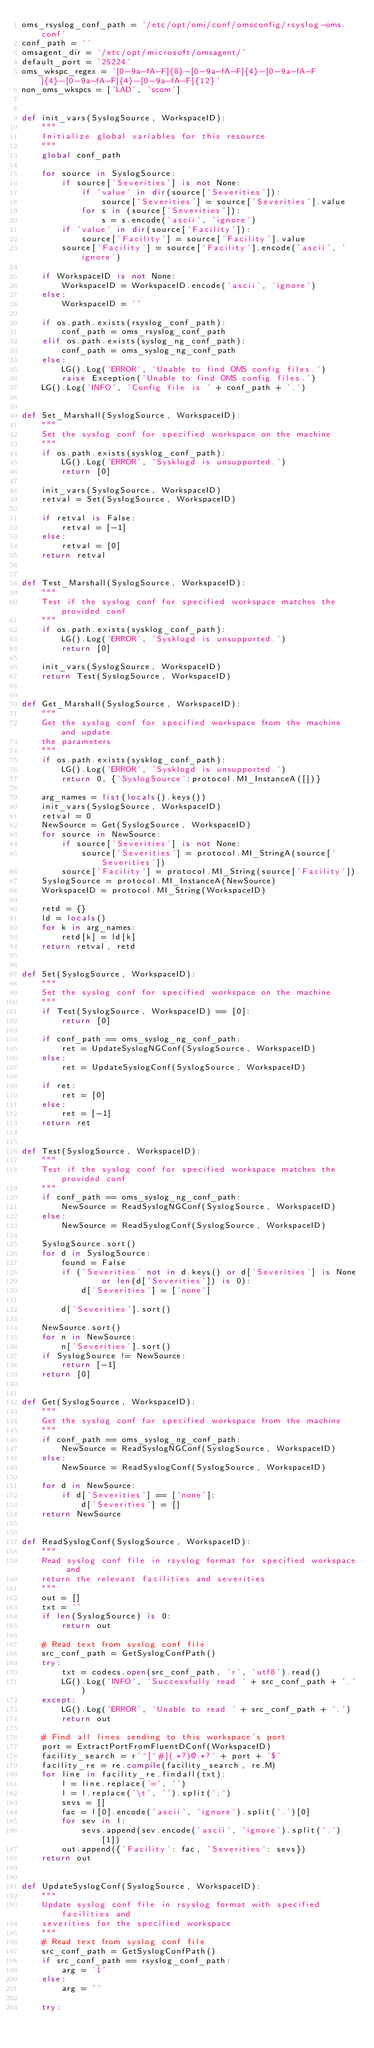<code> <loc_0><loc_0><loc_500><loc_500><_Python_>oms_rsyslog_conf_path = '/etc/opt/omi/conf/omsconfig/rsyslog-oms.conf'
conf_path = ''
omsagent_dir = '/etc/opt/microsoft/omsagent/'
default_port = '25224'
oms_wkspc_regex = '[0-9a-fA-F]{8}-[0-9a-fA-F]{4}-[0-9a-fA-F]{4}-[0-9a-fA-F]{4}-[0-9a-fA-F]{12}'
non_oms_wkspcs = ['LAD', 'scom']


def init_vars(SyslogSource, WorkspaceID):
    """
    Initialize global variables for this resource
    """
    global conf_path

    for source in SyslogSource:
        if source['Severities'] is not None:
            if 'value' in dir(source['Severities']):
                source['Severities'] = source['Severities'].value
            for s in (source['Severities']):
                s = s.encode('ascii', 'ignore')
        if 'value' in dir(source['Facility']):
            source['Facility'] = source['Facility'].value
        source['Facility'] = source['Facility'].encode('ascii', 'ignore')

    if WorkspaceID is not None:
        WorkspaceID = WorkspaceID.encode('ascii', 'ignore')
    else:
        WorkspaceID = ''

    if os.path.exists(rsyslog_conf_path):
        conf_path = oms_rsyslog_conf_path
    elif os.path.exists(syslog_ng_conf_path):
        conf_path = oms_syslog_ng_conf_path
    else:
        LG().Log('ERROR', 'Unable to find OMS config files.')
        raise Exception('Unable to find OMS config files.')
    LG().Log('INFO', 'Config file is ' + conf_path + '.')


def Set_Marshall(SyslogSource, WorkspaceID):
    """
    Set the syslog conf for specified workspace on the machine
    """
    if os.path.exists(sysklog_conf_path):
        LG().Log('ERROR', 'Sysklogd is unsupported.')
        return [0]

    init_vars(SyslogSource, WorkspaceID)
    retval = Set(SyslogSource, WorkspaceID)

    if retval is False:
        retval = [-1]
    else:
        retval = [0]
    return retval


def Test_Marshall(SyslogSource, WorkspaceID):
    """
    Test if the syslog conf for specified workspace matches the provided conf
    """
    if os.path.exists(sysklog_conf_path):
        LG().Log('ERROR', 'Sysklogd is unsupported.')
        return [0]

    init_vars(SyslogSource, WorkspaceID)
    return Test(SyslogSource, WorkspaceID)


def Get_Marshall(SyslogSource, WorkspaceID):
    """
    Get the syslog conf for specified workspace from the machine and update
    the parameters
    """
    if os.path.exists(sysklog_conf_path):
        LG().Log('ERROR', 'Sysklogd is unsupported.')
        return 0, {'SyslogSource':protocol.MI_InstanceA([])}

    arg_names = list(locals().keys())
    init_vars(SyslogSource, WorkspaceID)
    retval = 0
    NewSource = Get(SyslogSource, WorkspaceID)
    for source in NewSource:
        if source['Severities'] is not None:
            source['Severities'] = protocol.MI_StringA(source['Severities'])
        source['Facility'] = protocol.MI_String(source['Facility'])
    SyslogSource = protocol.MI_InstanceA(NewSource)
    WorkspaceID = protocol.MI_String(WorkspaceID)

    retd = {}
    ld = locals()
    for k in arg_names:
        retd[k] = ld[k]
    return retval, retd


def Set(SyslogSource, WorkspaceID):
    """
    Set the syslog conf for specified workspace on the machine
    """
    if Test(SyslogSource, WorkspaceID) == [0]:
        return [0]

    if conf_path == oms_syslog_ng_conf_path:
        ret = UpdateSyslogNGConf(SyslogSource, WorkspaceID)
    else:
        ret = UpdateSyslogConf(SyslogSource, WorkspaceID)

    if ret:
        ret = [0]
    else:
        ret = [-1]
    return ret


def Test(SyslogSource, WorkspaceID):
    """
    Test if the syslog conf for specified workspace matches the provided conf
    """
    if conf_path == oms_syslog_ng_conf_path:
        NewSource = ReadSyslogNGConf(SyslogSource, WorkspaceID)
    else:
        NewSource = ReadSyslogConf(SyslogSource, WorkspaceID)

    SyslogSource.sort()
    for d in SyslogSource:
        found = False
        if ('Severities' not in d.keys() or d['Severities'] is None 
                or len(d['Severities']) is 0):
            d['Severities'] = ['none']

        d['Severities'].sort()

    NewSource.sort()
    for n in NewSource:
        n['Severities'].sort()
    if SyslogSource != NewSource:
        return [-1]
    return [0]


def Get(SyslogSource, WorkspaceID):
    """
    Get the syslog conf for specified workspace from the machine
    """
    if conf_path == oms_syslog_ng_conf_path:
        NewSource = ReadSyslogNGConf(SyslogSource, WorkspaceID)
    else:
        NewSource = ReadSyslogConf(SyslogSource, WorkspaceID)

    for d in NewSource:
        if d['Severities'] == ['none']:
            d['Severities'] = []
    return NewSource


def ReadSyslogConf(SyslogSource, WorkspaceID):
    """
    Read syslog conf file in rsyslog format for specified workspace and
    return the relevant facilities and severities
    """
    out = []
    txt = ''
    if len(SyslogSource) is 0:
        return out

    # Read text from syslog conf file
    src_conf_path = GetSyslogConfPath()
    try:
        txt = codecs.open(src_conf_path, 'r', 'utf8').read()
        LG().Log('INFO', 'Successfully read ' + src_conf_path + '.')
    except:
        LG().Log('ERROR', 'Unable to read ' + src_conf_path + '.')
        return out

    # Find all lines sending to this workspace's port
    port = ExtractPortFromFluentDConf(WorkspaceID)
    facility_search = r'^[^#](.*?)@.*?' + port + '$'
    facility_re = re.compile(facility_search, re.M)
    for line in facility_re.findall(txt):
        l = line.replace('=', '')
        l = l.replace('\t', '').split(';')
        sevs = []
        fac = l[0].encode('ascii', 'ignore').split('.')[0]
        for sev in l:
            sevs.append(sev.encode('ascii', 'ignore').split('.')[1])
        out.append({'Facility': fac, 'Severities': sevs})
    return out


def UpdateSyslogConf(SyslogSource, WorkspaceID):
    """
    Update syslog conf file in rsyslog format with specified facilities and
    severities for the specified workspace
    """
    # Read text from syslog conf file
    src_conf_path = GetSyslogConfPath()
    if src_conf_path == rsyslog_conf_path:
        arg = '1'
    else:
        arg = ''

    try:</code> 